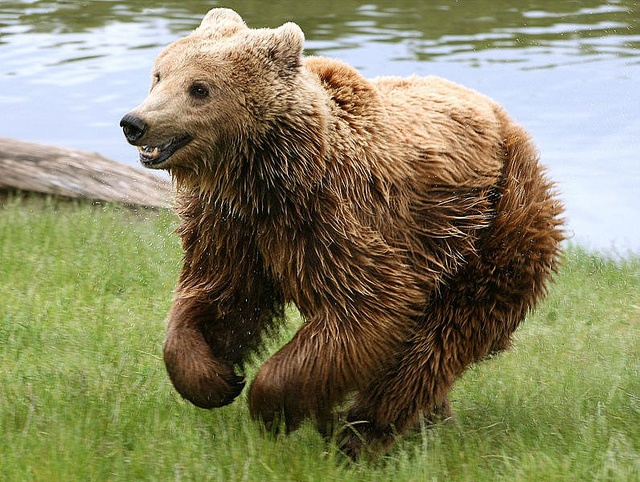Describe the objects in this image and their specific colors. I can see a bear in lightgray, black, maroon, and gray tones in this image. 